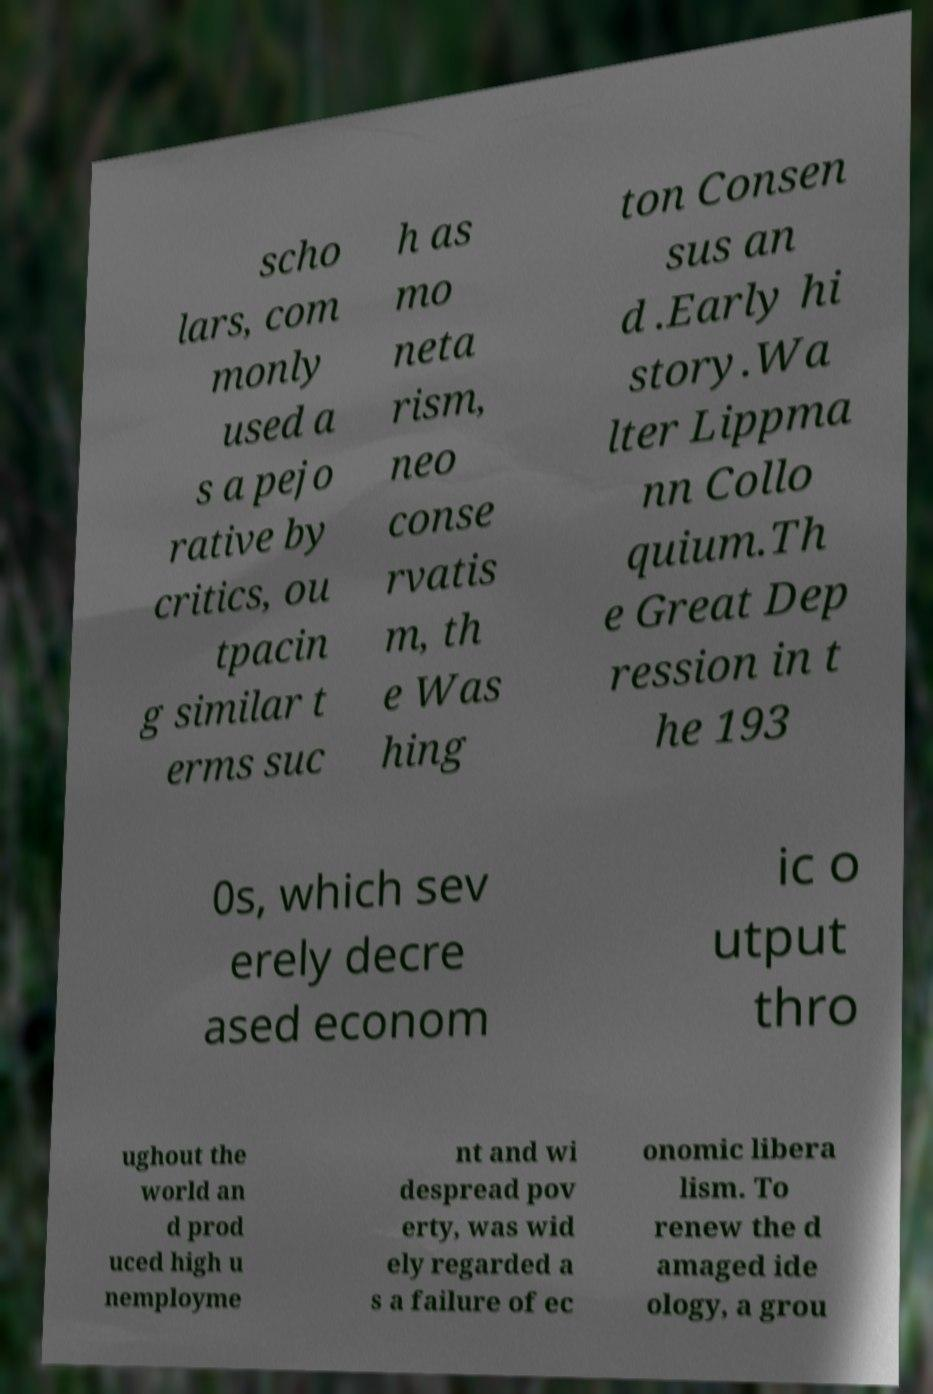Could you assist in decoding the text presented in this image and type it out clearly? scho lars, com monly used a s a pejo rative by critics, ou tpacin g similar t erms suc h as mo neta rism, neo conse rvatis m, th e Was hing ton Consen sus an d .Early hi story.Wa lter Lippma nn Collo quium.Th e Great Dep ression in t he 193 0s, which sev erely decre ased econom ic o utput thro ughout the world an d prod uced high u nemployme nt and wi despread pov erty, was wid ely regarded a s a failure of ec onomic libera lism. To renew the d amaged ide ology, a grou 